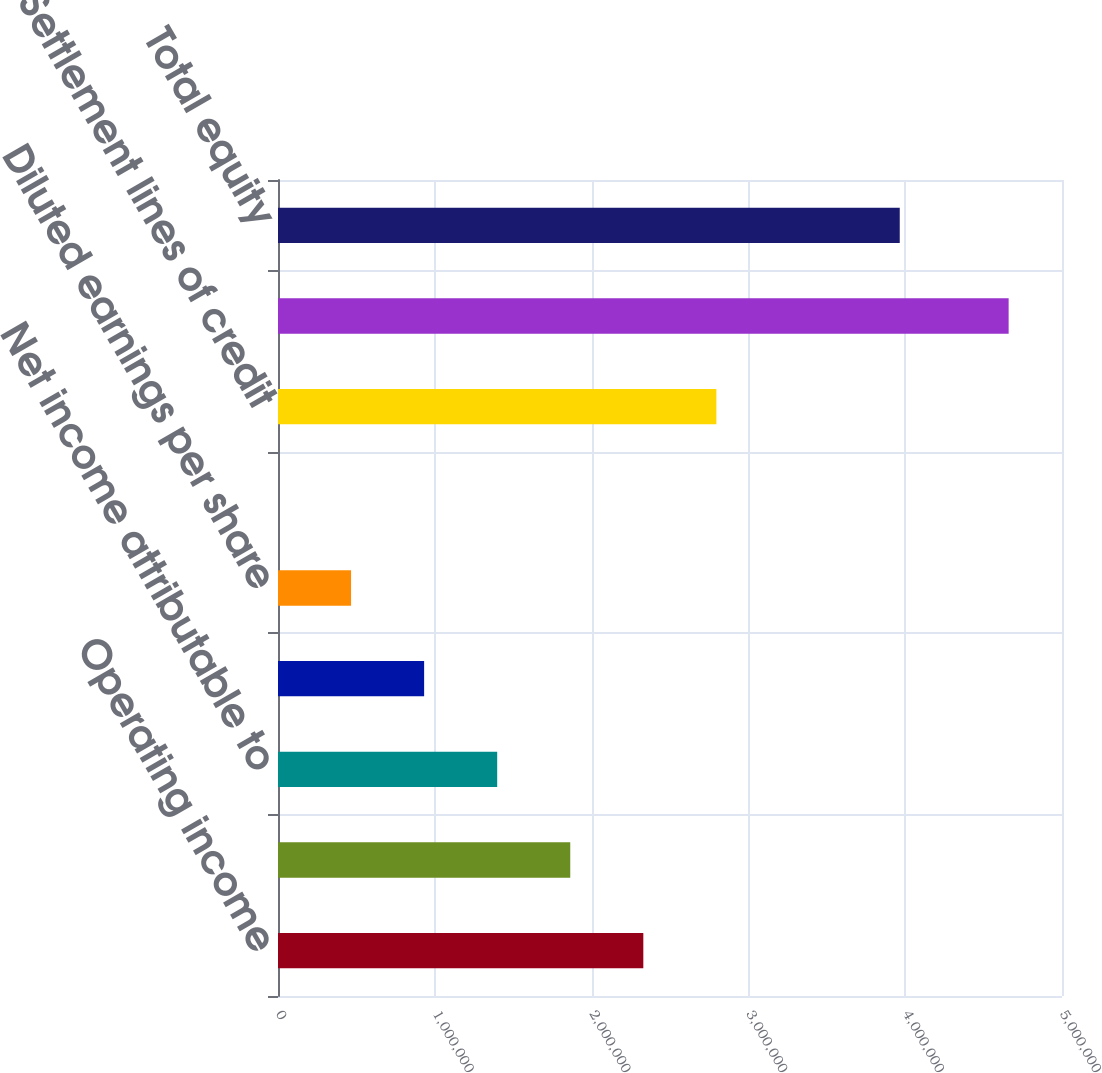Convert chart to OTSL. <chart><loc_0><loc_0><loc_500><loc_500><bar_chart><fcel>Operating income<fcel>Net income<fcel>Net income attributable to<fcel>Basic earnings per share<fcel>Diluted earnings per share<fcel>Dividends per share<fcel>Settlement lines of credit<fcel>Long-term debt<fcel>Total equity<nl><fcel>2.32986e+06<fcel>1.86389e+06<fcel>1.39791e+06<fcel>931943<fcel>465972<fcel>0.04<fcel>2.79583e+06<fcel>4.65972e+06<fcel>3.96523e+06<nl></chart> 